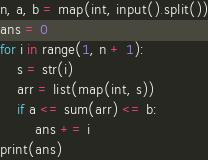Convert code to text. <code><loc_0><loc_0><loc_500><loc_500><_Python_>n, a, b = map(int, input().split())
ans = 0
for i in range(1, n + 1):
    s = str(i)
    arr = list(map(int, s))
    if a <= sum(arr) <= b:
        ans += i
print(ans)
</code> 